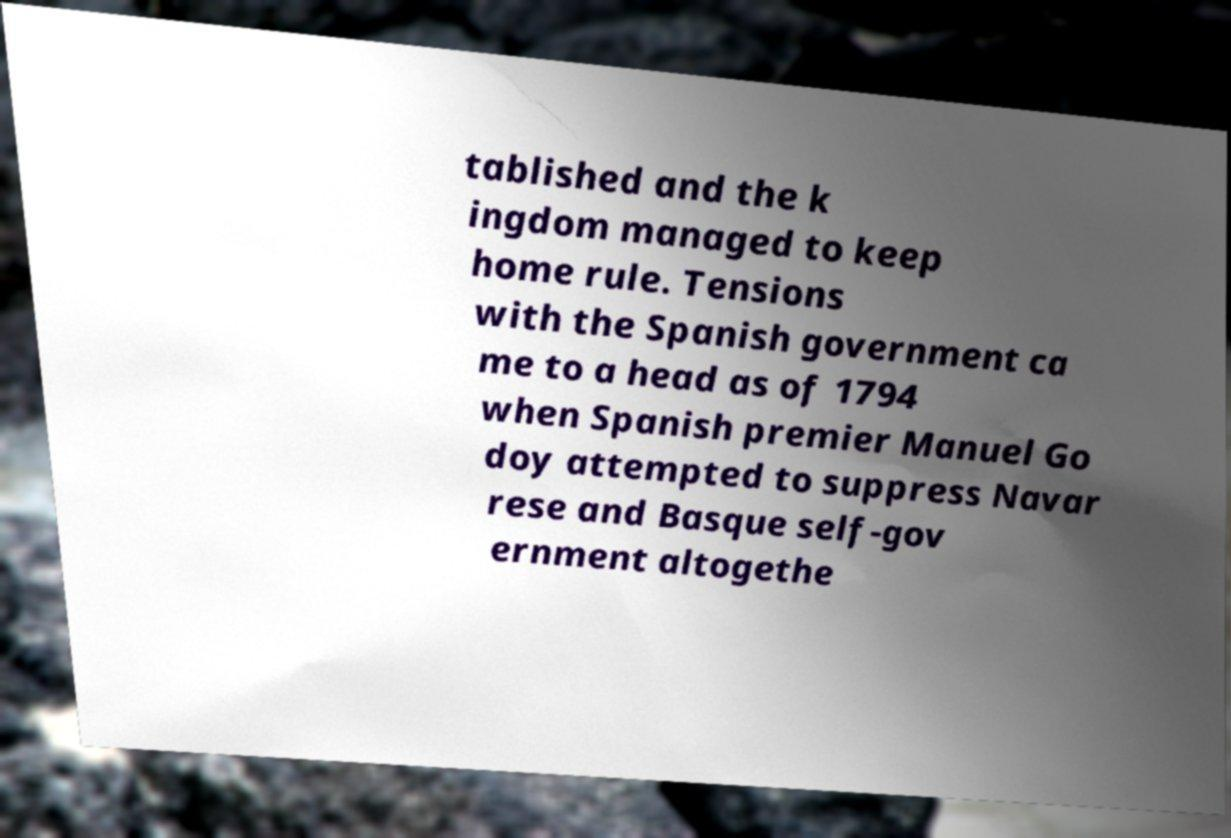Could you assist in decoding the text presented in this image and type it out clearly? tablished and the k ingdom managed to keep home rule. Tensions with the Spanish government ca me to a head as of 1794 when Spanish premier Manuel Go doy attempted to suppress Navar rese and Basque self-gov ernment altogethe 